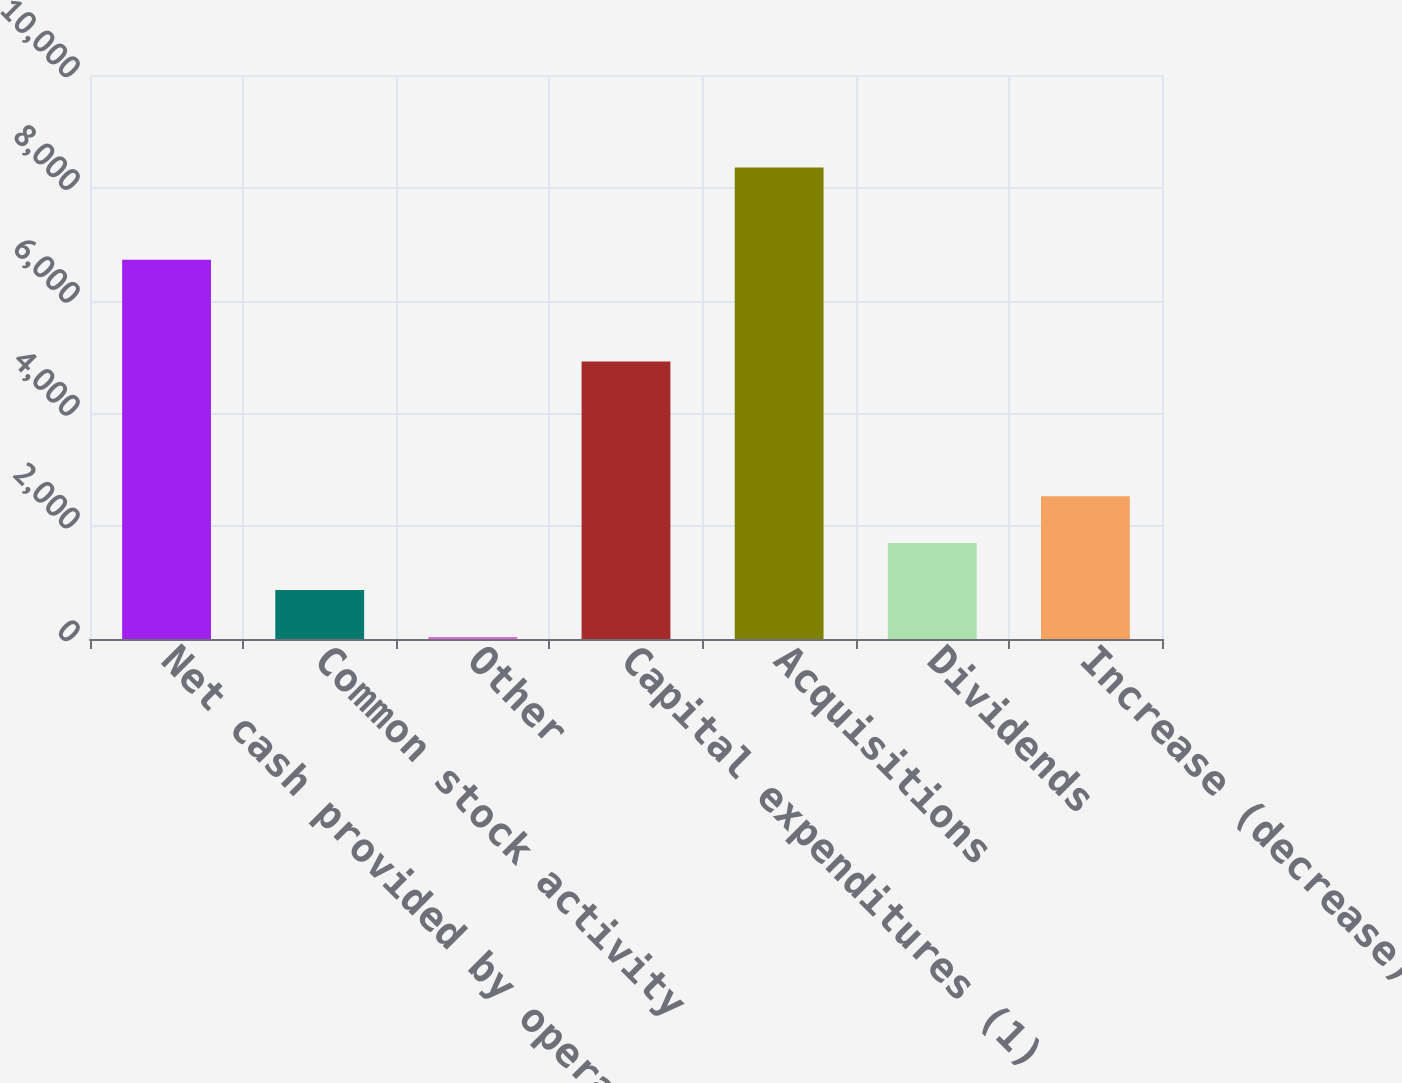Convert chart. <chart><loc_0><loc_0><loc_500><loc_500><bar_chart><fcel>Net cash provided by operating<fcel>Common stock activity<fcel>Other<fcel>Capital expenditures (1)<fcel>Acquisitions<fcel>Dividends<fcel>Increase (decrease) in cash<nl><fcel>6726<fcel>868.4<fcel>36<fcel>4922<fcel>8360<fcel>1700.8<fcel>2533.2<nl></chart> 